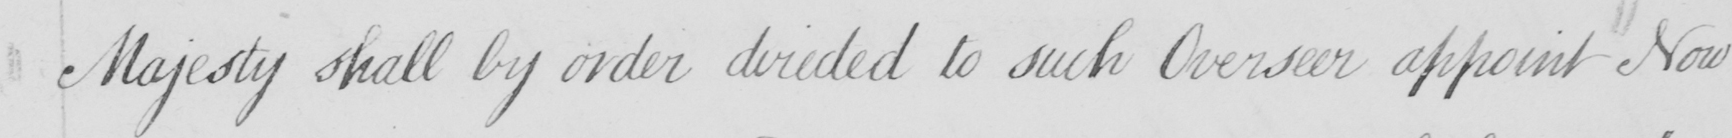Can you tell me what this handwritten text says? Majesty shall by order directed to such Overseer appoint Now 